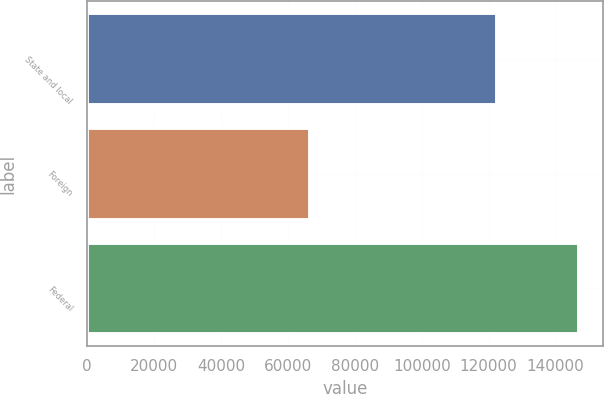<chart> <loc_0><loc_0><loc_500><loc_500><bar_chart><fcel>State and local<fcel>Foreign<fcel>Federal<nl><fcel>122396<fcel>66610<fcel>146872<nl></chart> 